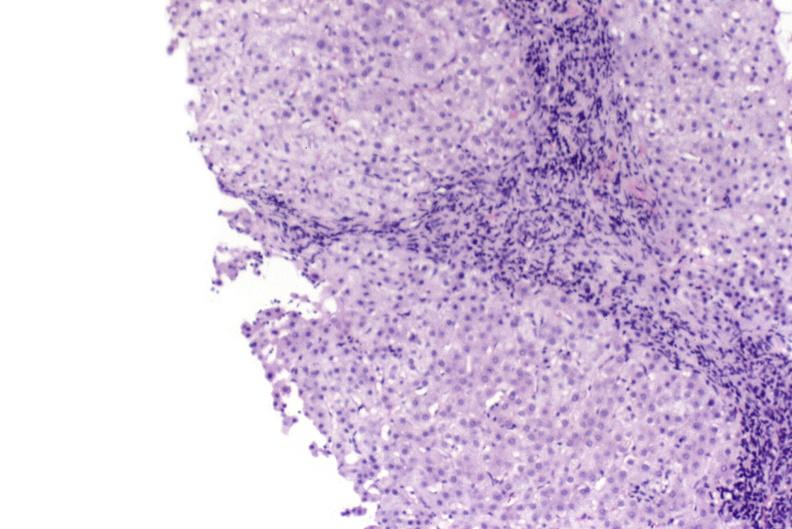what does this image show?
Answer the question using a single word or phrase. Primary biliary cirrhosis 